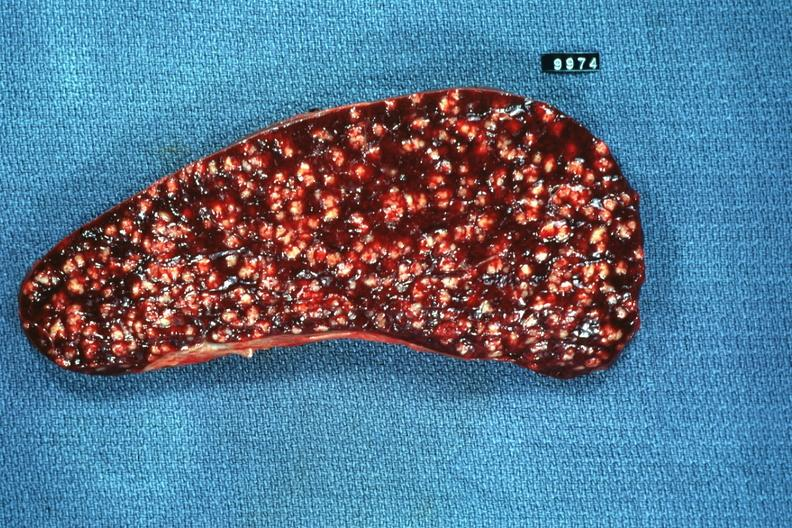what is present?
Answer the question using a single word or phrase. Miliary tuberculosis 